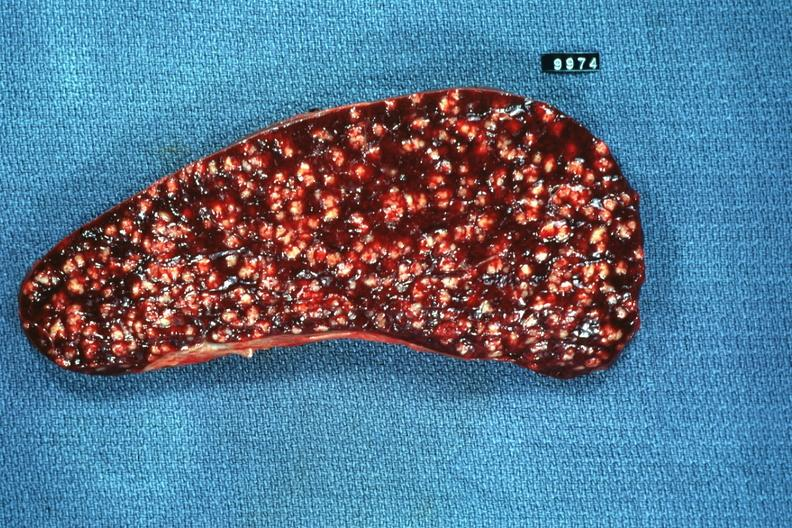what is present?
Answer the question using a single word or phrase. Miliary tuberculosis 